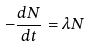Convert formula to latex. <formula><loc_0><loc_0><loc_500><loc_500>- \frac { d N } { d t } = \lambda N</formula> 